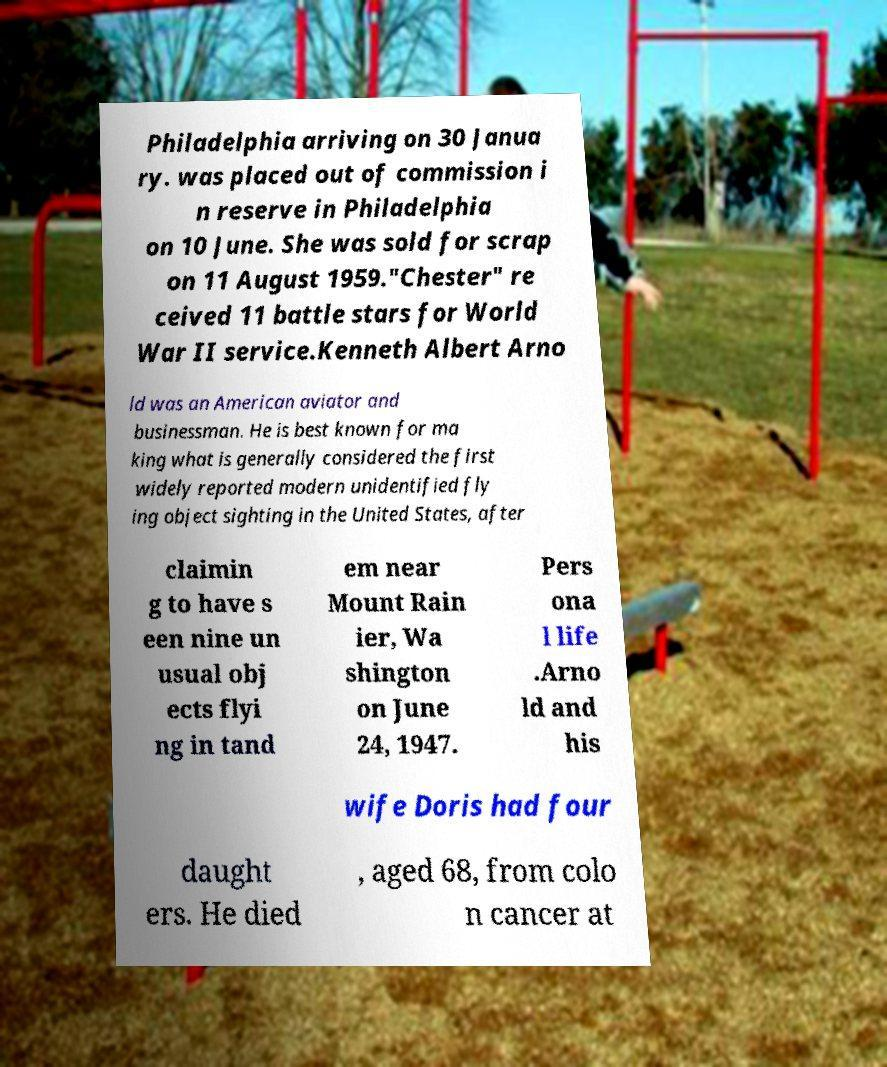For documentation purposes, I need the text within this image transcribed. Could you provide that? Philadelphia arriving on 30 Janua ry. was placed out of commission i n reserve in Philadelphia on 10 June. She was sold for scrap on 11 August 1959."Chester" re ceived 11 battle stars for World War II service.Kenneth Albert Arno ld was an American aviator and businessman. He is best known for ma king what is generally considered the first widely reported modern unidentified fly ing object sighting in the United States, after claimin g to have s een nine un usual obj ects flyi ng in tand em near Mount Rain ier, Wa shington on June 24, 1947. Pers ona l life .Arno ld and his wife Doris had four daught ers. He died , aged 68, from colo n cancer at 